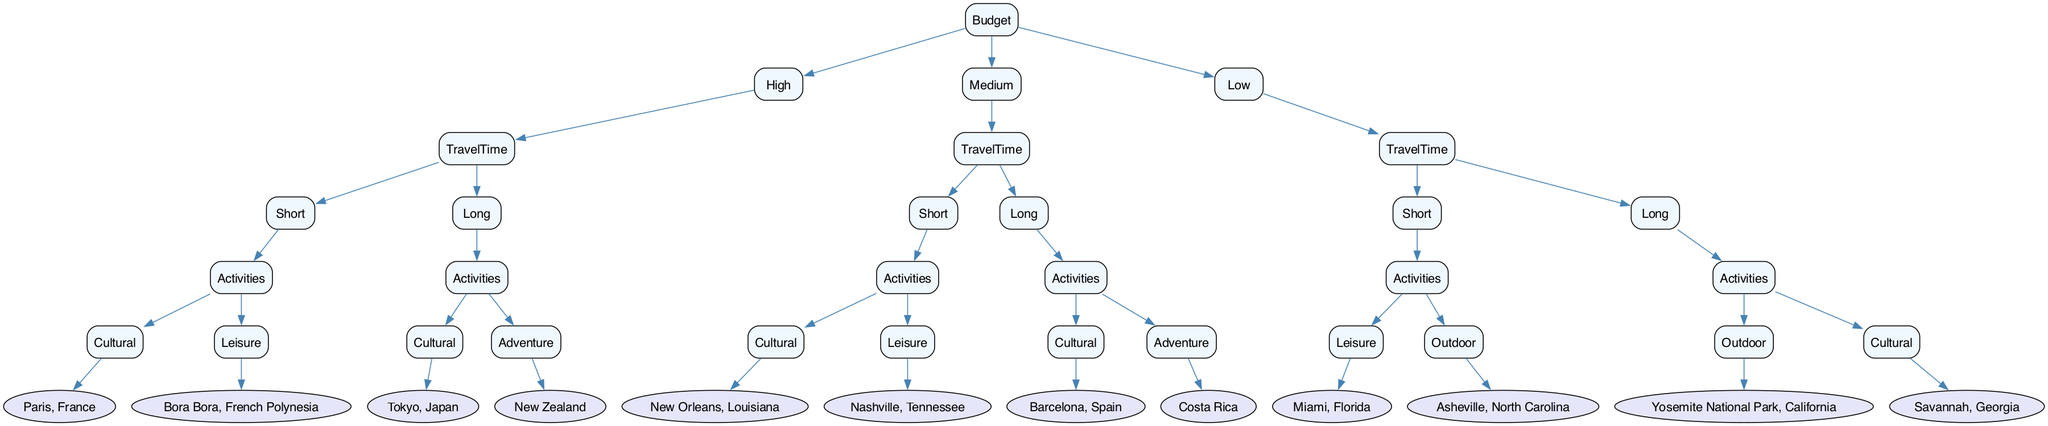What is the vacation destination for a high budget with short travel time and cultural activities? According to the diagram, for a high budget and short travel time, the destination is Paris, France since it falls under the "Cultural" activities branch.
Answer: Paris, France How many destinations are listed for a low budget and long travel time? In the decision tree, under low budget for long travel time, there are two listed activities: Outdoor in Yosemite National Park, California and Cultural in Savannah, Georgia. This totals to two destinations.
Answer: 2 What are the leisure activity destinations for a medium budget? For a medium budget, the leisure destination for short travel time is Nashville, Tennessee. This is the only leisure activity listed under medium budget in the decision tree.
Answer: Nashville, Tennessee If the budget is medium, what is the cultural destination for long travel time? In the decision tree, if the budget is medium and the travel time is long, the cultural destination is Barcelona, Spain, as it is the only cultural option presented.
Answer: Barcelona, Spain What is the destination for a low budget and short travel time for leisure activities? Based on the decision tree, under low budget and short travel time, the leisure destination is Miami, Florida, which is specified as the leisure activity option.
Answer: Miami, Florida How many branches does the decision tree have for travel time under a high budget? The decision tree has two distinct branches under the high budget category based on travel time: one for short travel time and another for long travel time. This totals to two branches.
Answer: 2 What destination corresponds to a long travel time and high budget with adventure activities? For a high budget and long travel time with adventure activities, the destination in the decision tree is New Zealand, which is specified under the adventure activities branch.
Answer: New Zealand What is the cultural activity destination for a low budget and long travel time? According to the diagram, the cultural activity destination for low budget and long travel time is Savannah, Georgia, which is explicitly listed under that category.
Answer: Savannah, Georgia 